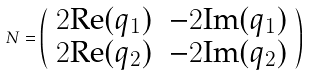Convert formula to latex. <formula><loc_0><loc_0><loc_500><loc_500>N = \left ( \begin{array} { c c } 2 \text {Re} ( q _ { 1 } ) & - 2 \text {Im} ( q _ { 1 } ) \\ 2 \text {Re} ( q _ { 2 } ) & - 2 \text {Im} ( q _ { 2 } ) \end{array} \right )</formula> 